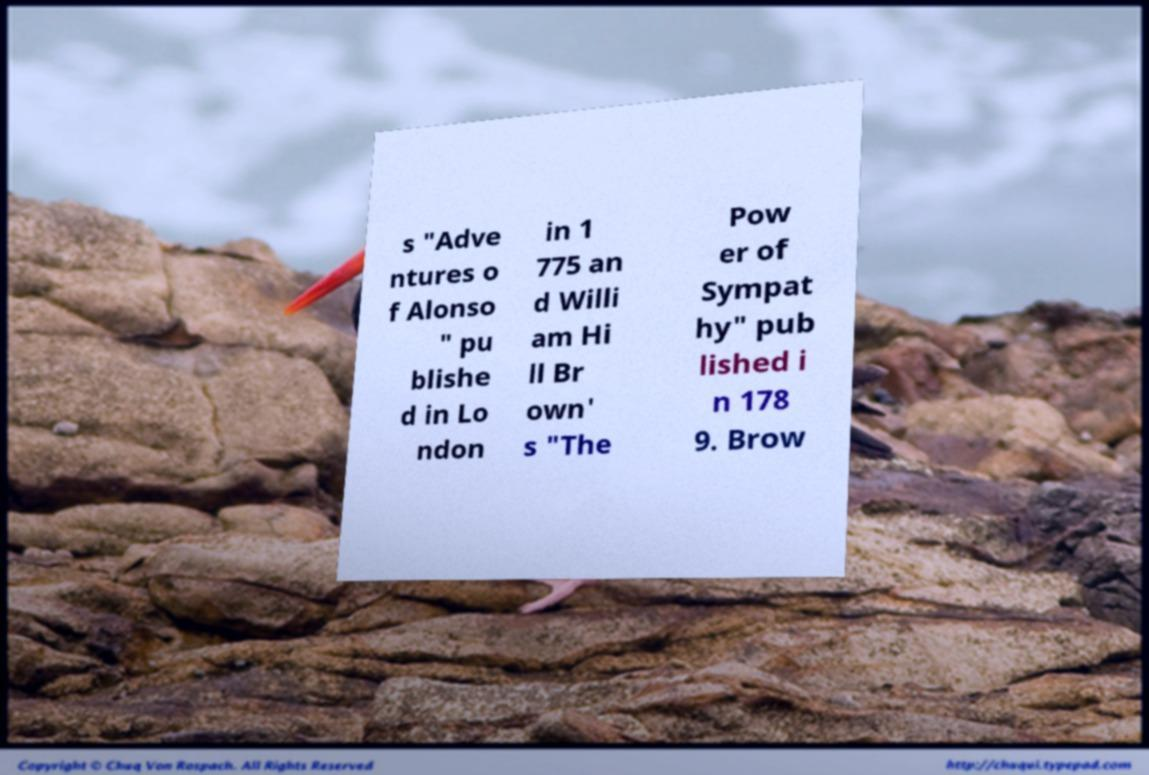There's text embedded in this image that I need extracted. Can you transcribe it verbatim? s "Adve ntures o f Alonso " pu blishe d in Lo ndon in 1 775 an d Willi am Hi ll Br own' s "The Pow er of Sympat hy" pub lished i n 178 9. Brow 